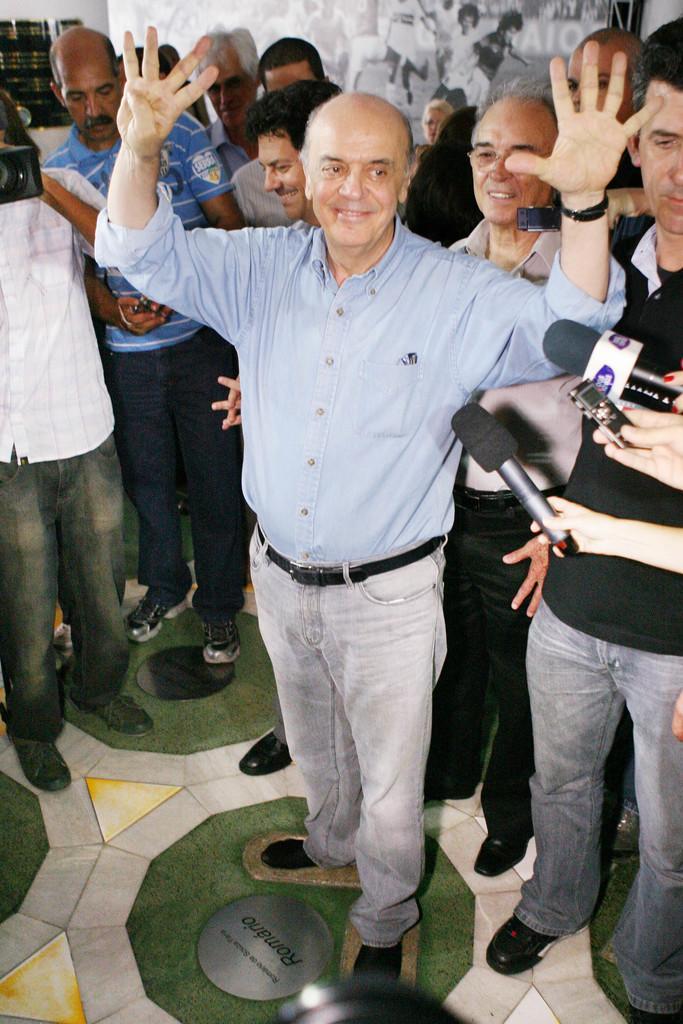Can you describe this image briefly? In front of the image there are people standing on the floor. On the right side of the image there are a few people holding the mikes. In the background of the image there is a board. On the left side of the image there is some object on the wall. 